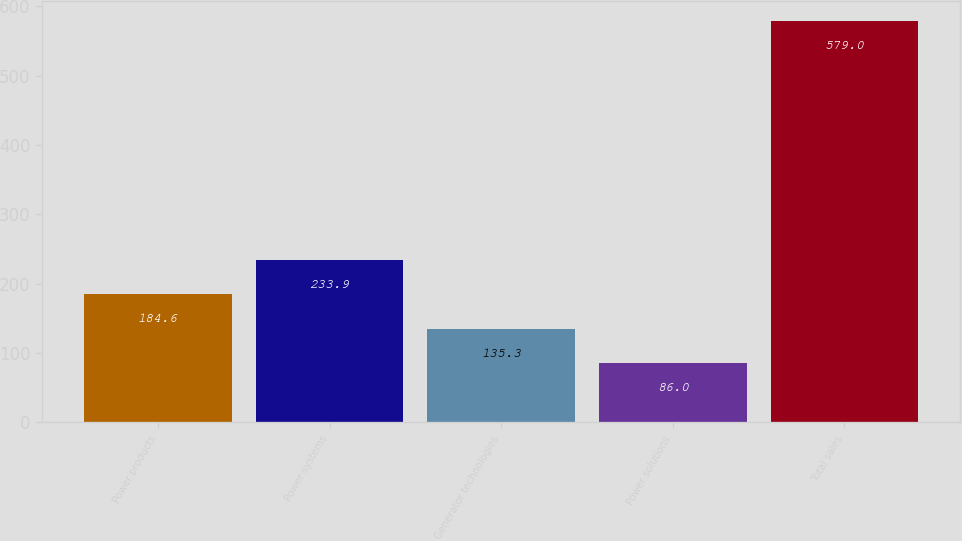Convert chart. <chart><loc_0><loc_0><loc_500><loc_500><bar_chart><fcel>Power products<fcel>Power systems<fcel>Generator technologies<fcel>Power solutions<fcel>Total sales<nl><fcel>184.6<fcel>233.9<fcel>135.3<fcel>86<fcel>579<nl></chart> 